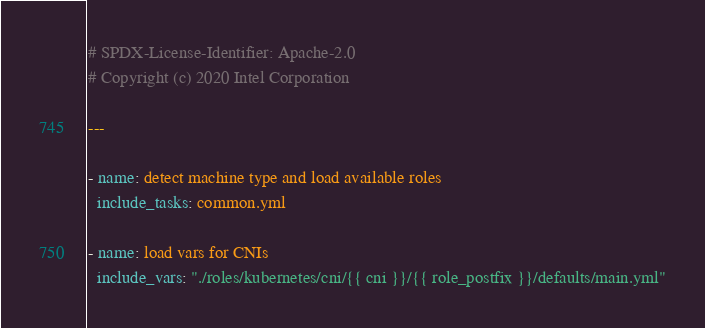<code> <loc_0><loc_0><loc_500><loc_500><_YAML_># SPDX-License-Identifier: Apache-2.0
# Copyright (c) 2020 Intel Corporation

---

- name: detect machine type and load available roles
  include_tasks: common.yml

- name: load vars for CNIs
  include_vars: "./roles/kubernetes/cni/{{ cni }}/{{ role_postfix }}/defaults/main.yml"</code> 